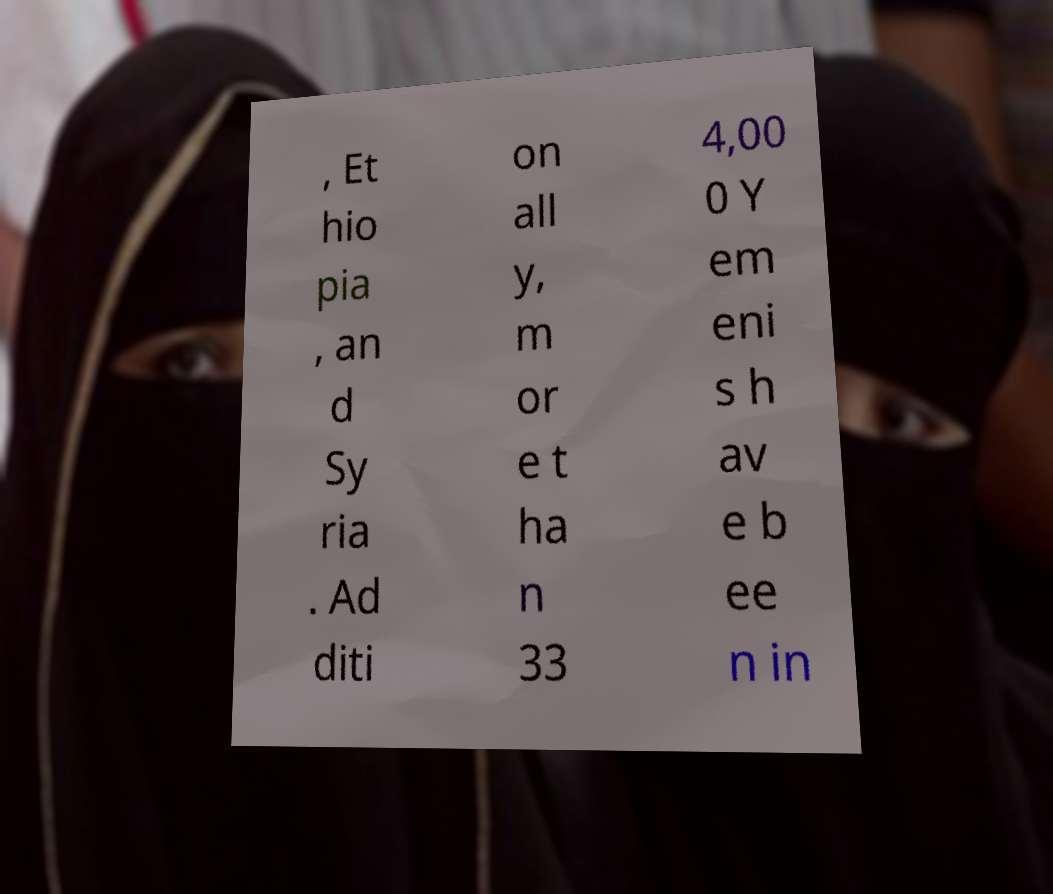Please read and relay the text visible in this image. What does it say? , Et hio pia , an d Sy ria . Ad diti on all y, m or e t ha n 33 4,00 0 Y em eni s h av e b ee n in 